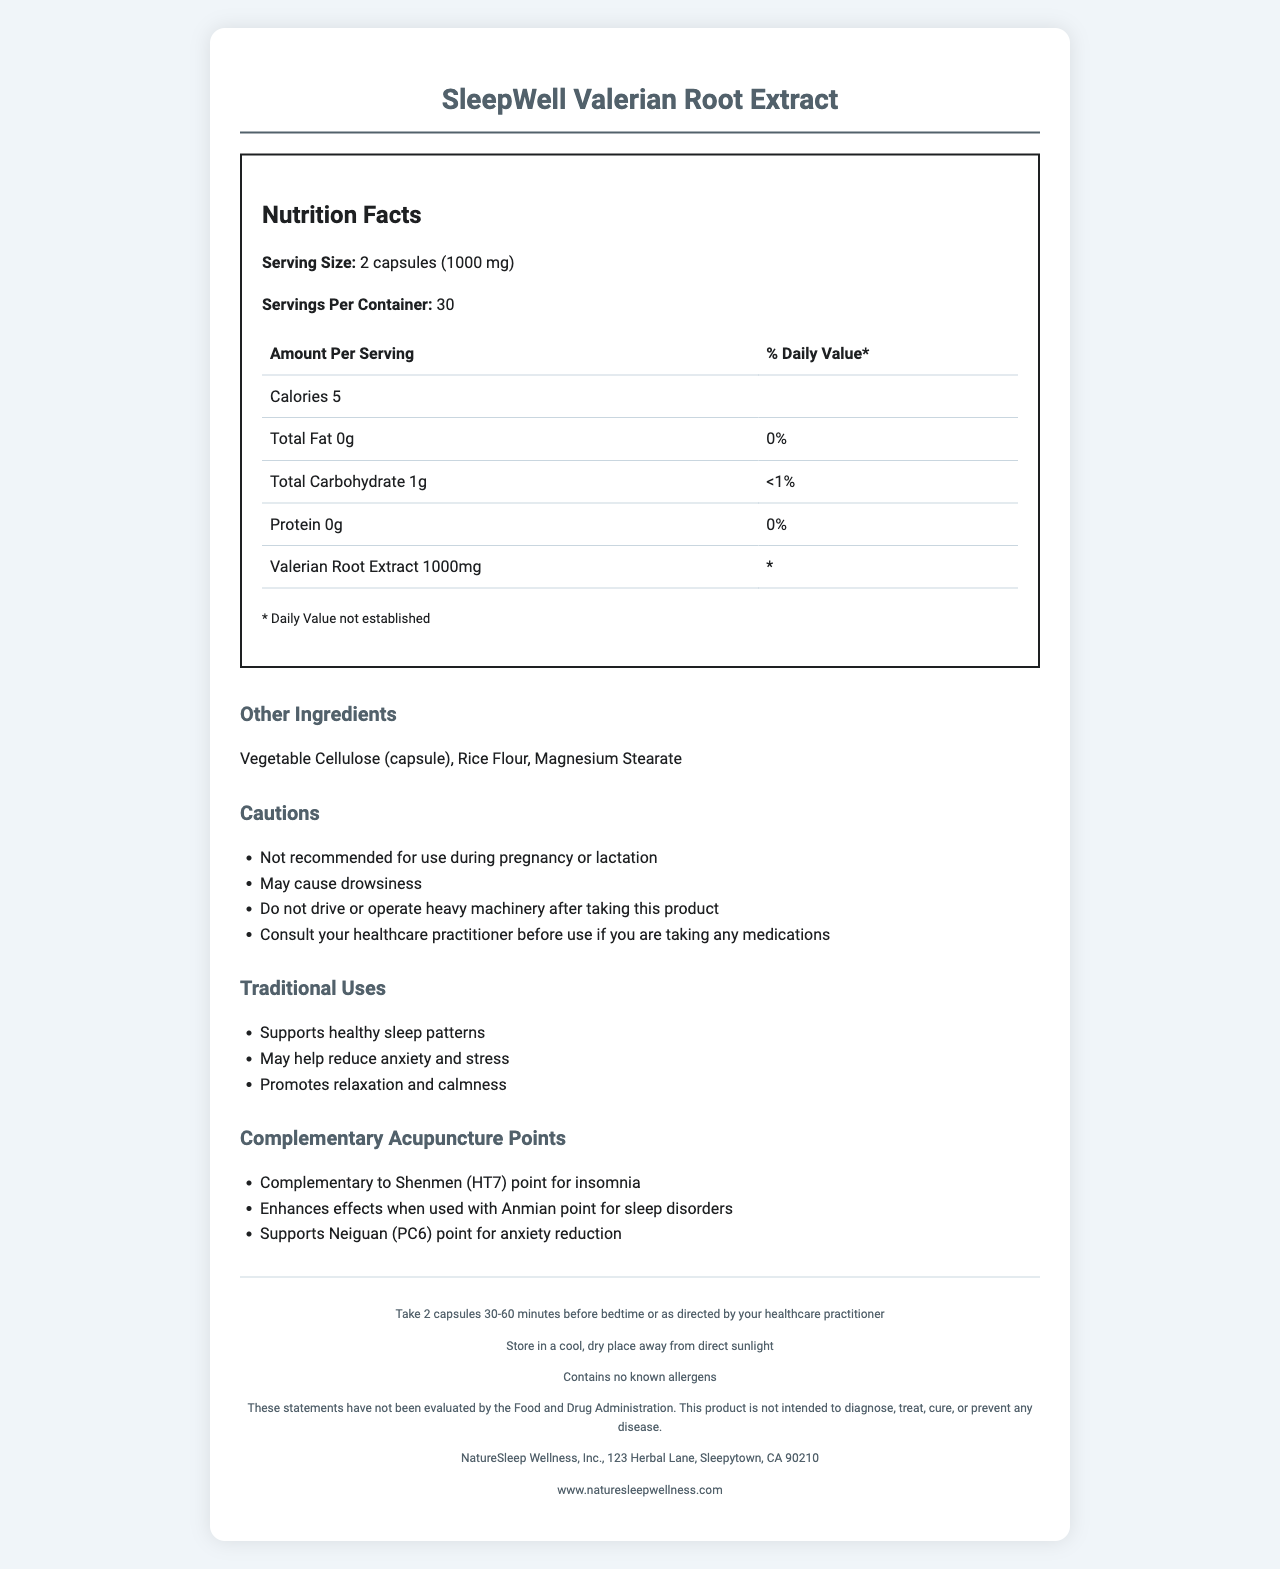what is the serving size for the SleepWell Valerian Root Extract? The document states that the serving size for the product is 2 capsules (1000 mg).
Answer: 2 capsules (1000 mg) how many calories are in a serving of SleepWell Valerian Root Extract? The document lists the amount per serving and mentions that there are 5 calories per serving.
Answer: 5 calories which ingredient in SleepWell Valerian Root Extract supports healthy sleep patterns? The Traditional Uses section of the document states that Valerian Root Extract supports healthy sleep patterns.
Answer: Valerian Root Extract how many servings are there in one container of SleepWell Valerian Root Extract? The document specifies that there are 30 servings per container.
Answer: 30 what are the possible side effects or cautions listed for SleepWell Valerian Root Extract? The Cautions section lists these warnings about potential side effects and cautions.
Answer: May cause drowsiness, not recommended for use during pregnancy or lactation, do not drive or operate heavy machinery after taking this product, consult your healthcare practitioner before use if you are taking any medications which acupuncture point is recommended for enhancing sleep when using SleepWell Valerian Root Extract? A. Shenmen (HT7) B. Anmian C. Neiguan (PC6) D. Both A and B The Acupuncture Points section mentions that the product is complementary to Shenmen (HT7) for insomnia and enhances effects when used with Anmian for sleep disorders.
Answer: D. Both A and B what is the recommended use of SleepWell Valerian Root Extract? A. Take 1 capsule before bedtime B. Take 2 capsules 30-60 minutes before bedtime The document states in the Suggested Use section that you should take 2 capsules 30-60 minutes before bedtime.
Answer: B. Take 2 capsules 30-60 minutes before bedtime does SleepWell Valerian Root Extract contain any known allergens? The Allergen Information section explicitly states that the product contains no known allergens.
Answer: No summarize the main benefits and uses of SleepWell Valerian Root Extract. The document highlights that the product is traditionally used for improving sleep, reducing anxiety, and promoting relaxation. It also suggests how to use the product and notes complementary acupuncture points for additional benefits.
Answer: SleepWell Valerian Root Extract supports healthy sleep patterns, may reduce anxiety and stress, and promotes relaxation and calmness. It is recommended to take 2 capsules 30-60 minutes before bedtime and is complemented by using specific acupuncture points for enhanced effects. what is the address of the manufacturer of SleepWell Valerian Root Extract? The document lists the manufacturer's address at 123 Herbal Lane, Sleepytown, CA 90210.
Answer: 123 Herbal Lane, Sleepytown, CA 90210 where should SleepWell Valerian Root Extract be stored? The Storage section of the document advises storing the product in a cool, dry place away from direct sunlight.
Answer: In a cool, dry place away from direct sunlight how much protein is in a serving of SleepWell Valerian Root Extract? The Amount Per Serving section lists 0g of protein per serving.
Answer: 0g how does SleepWell Valerian Root Extract affect daily carbohydrate intake? The document mentions that a serving of SleepWell Valerian Root Extract contains less than 1% of the daily Value for carbohydrates.
Answer: Less than 1% cannot be determined from this document: what is the shelf life of SleepWell Valerian Root Extract? The document does not provide any information regarding the shelf life of the product.
Answer: Cannot be determined 